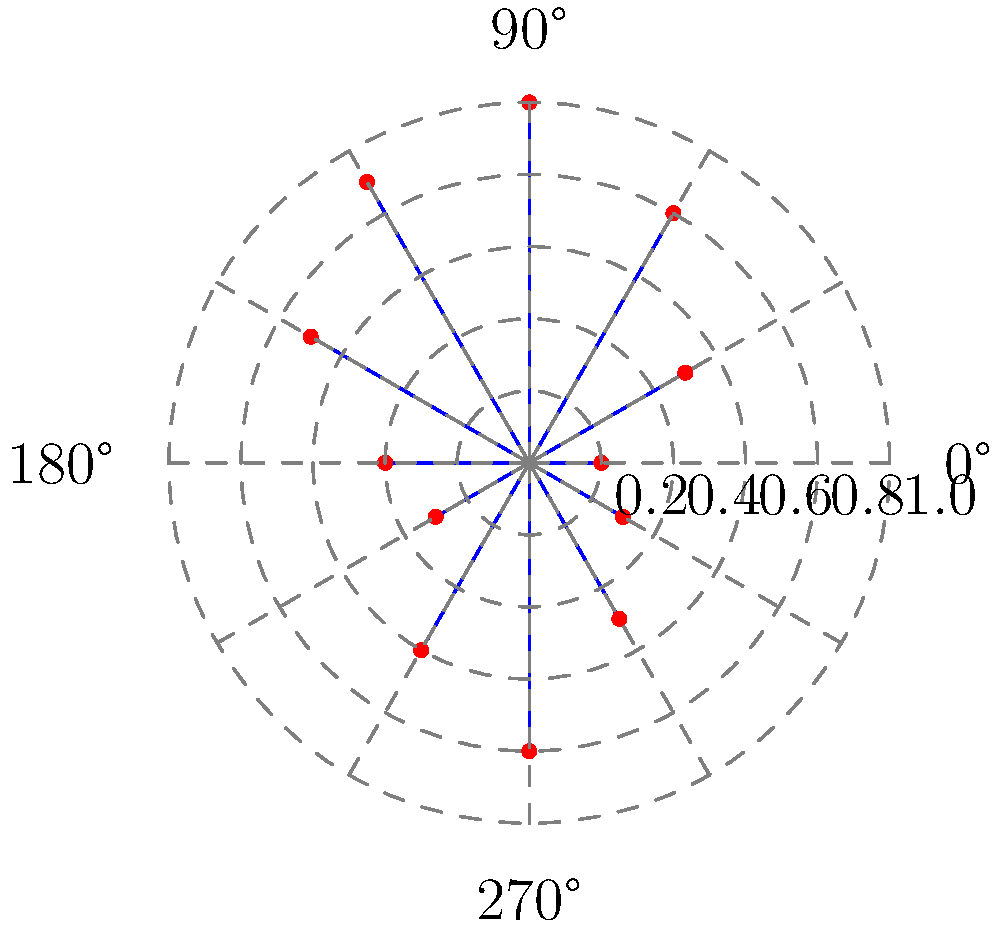In a pharmaceutical formulation, particle size distribution is represented using a polar coordinate system. The angle represents the particle size (in micrometers), and the radius represents the relative frequency of particles at that size. Based on the given polar plot, at which particle size (in degrees) does the formulation have the highest relative frequency of particles? To determine the particle size with the highest relative frequency, we need to analyze the polar plot step-by-step:

1. In this polar coordinate system, the angle represents particle size in micrometers, while the radius represents the relative frequency.

2. The concentric circles represent different levels of relative frequency, with the outermost circle representing a frequency of 1.0.

3. We need to identify the point that extends furthest from the center, as this represents the highest relative frequency.

4. Examining the plot, we can see that the longest line extends to the outermost circle (radius = 1.0).

5. This longest line is at an angle of 90° from the positive x-axis.

6. Therefore, the particle size corresponding to 90° has the highest relative frequency in the formulation.
Answer: 90° 